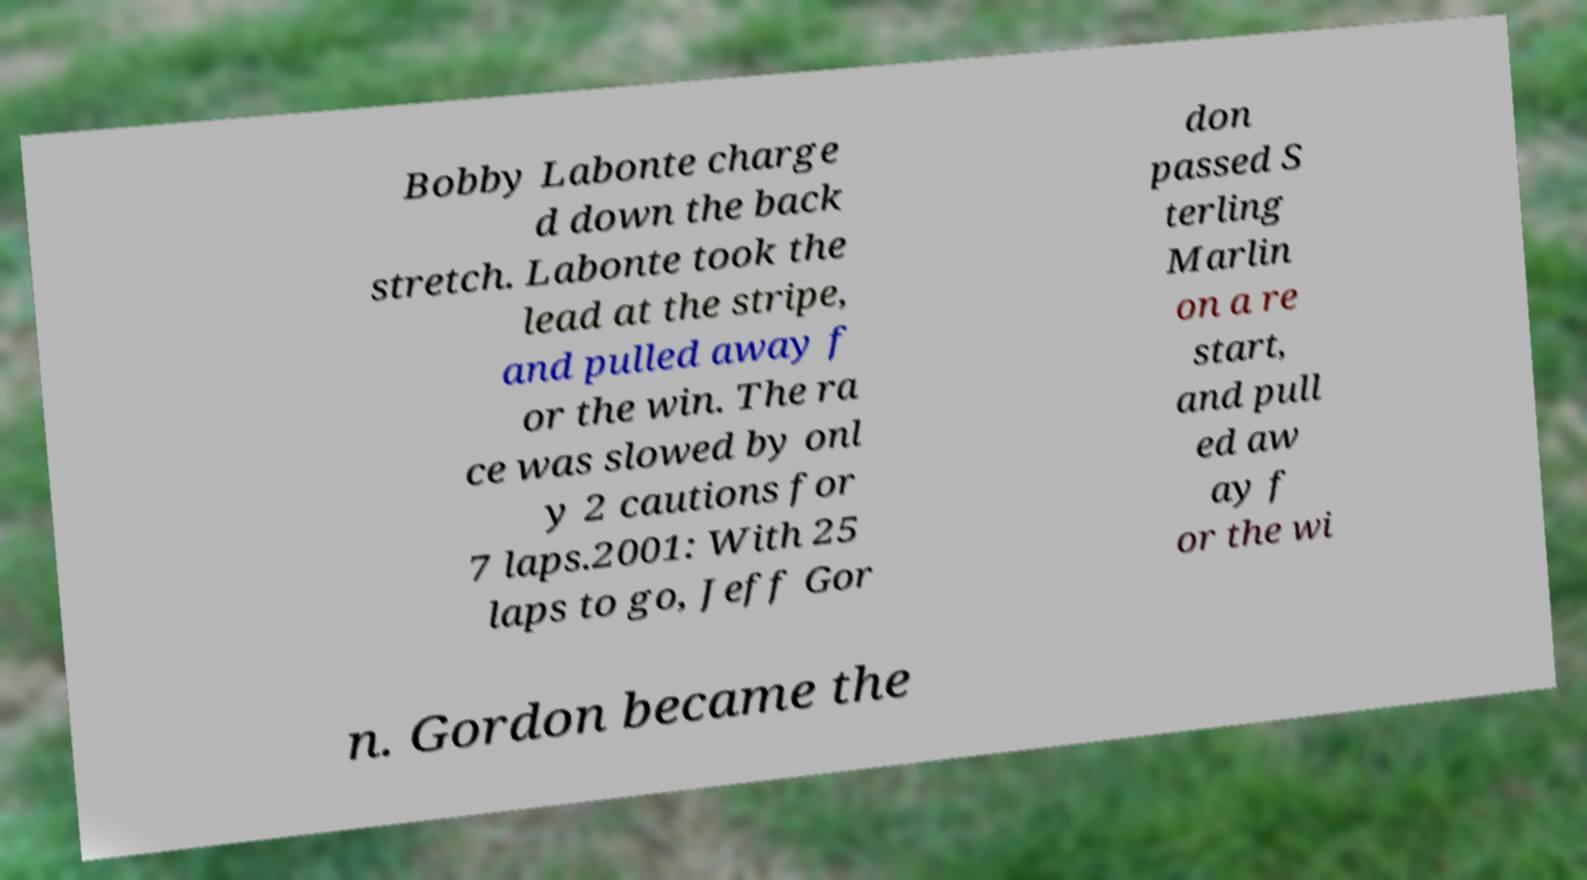Can you accurately transcribe the text from the provided image for me? Bobby Labonte charge d down the back stretch. Labonte took the lead at the stripe, and pulled away f or the win. The ra ce was slowed by onl y 2 cautions for 7 laps.2001: With 25 laps to go, Jeff Gor don passed S terling Marlin on a re start, and pull ed aw ay f or the wi n. Gordon became the 